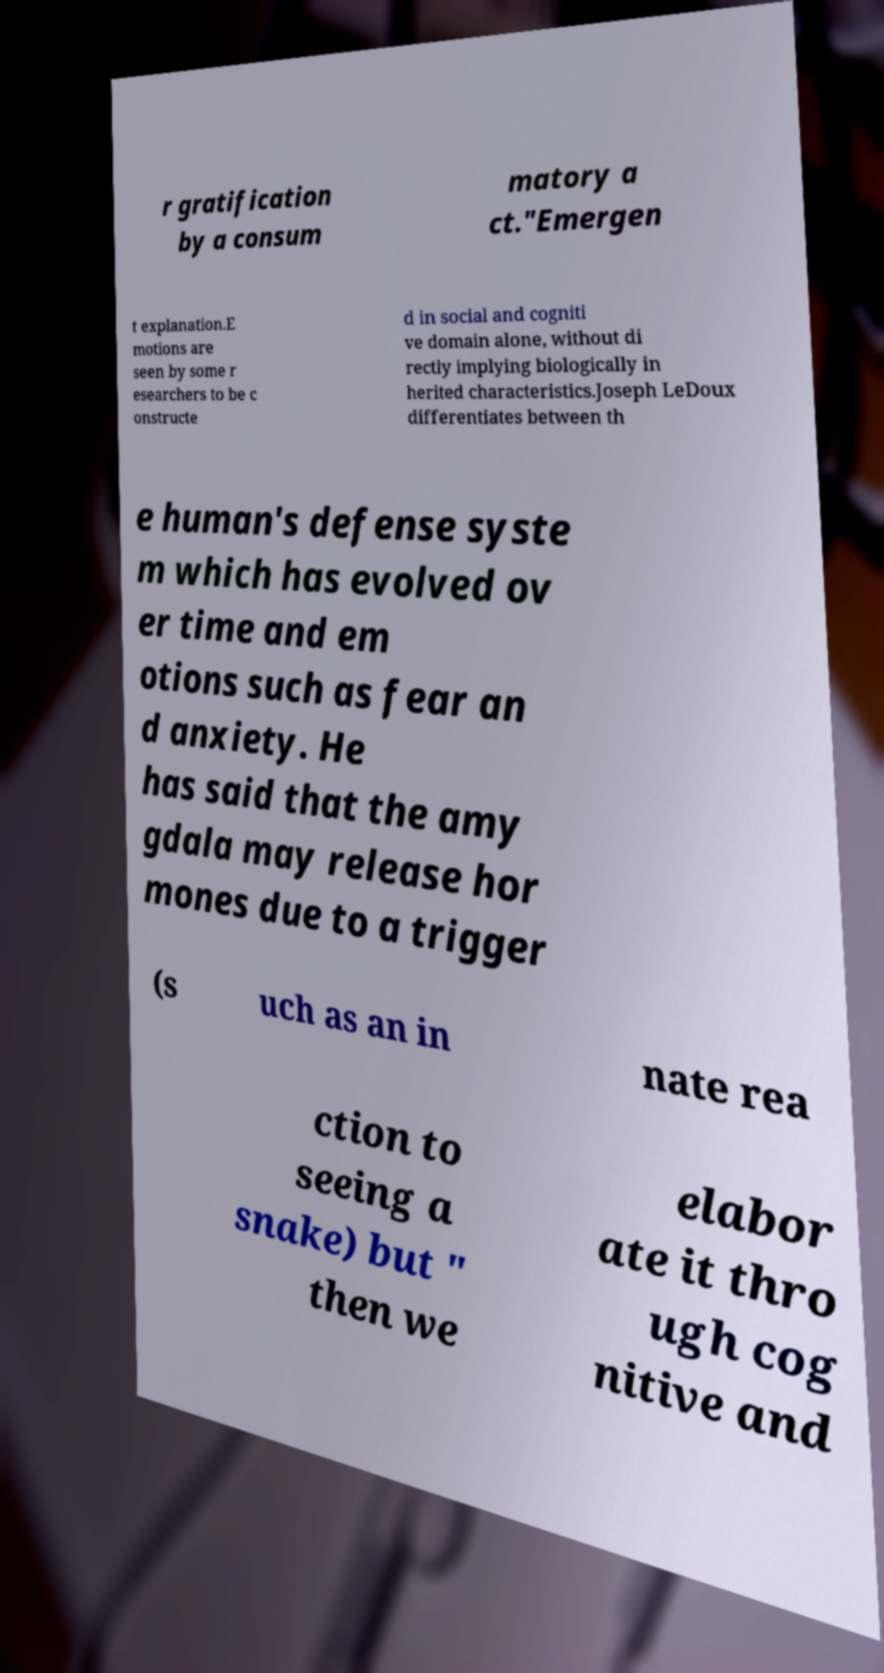Can you accurately transcribe the text from the provided image for me? r gratification by a consum matory a ct."Emergen t explanation.E motions are seen by some r esearchers to be c onstructe d in social and cogniti ve domain alone, without di rectly implying biologically in herited characteristics.Joseph LeDoux differentiates between th e human's defense syste m which has evolved ov er time and em otions such as fear an d anxiety. He has said that the amy gdala may release hor mones due to a trigger (s uch as an in nate rea ction to seeing a snake) but " then we elabor ate it thro ugh cog nitive and 